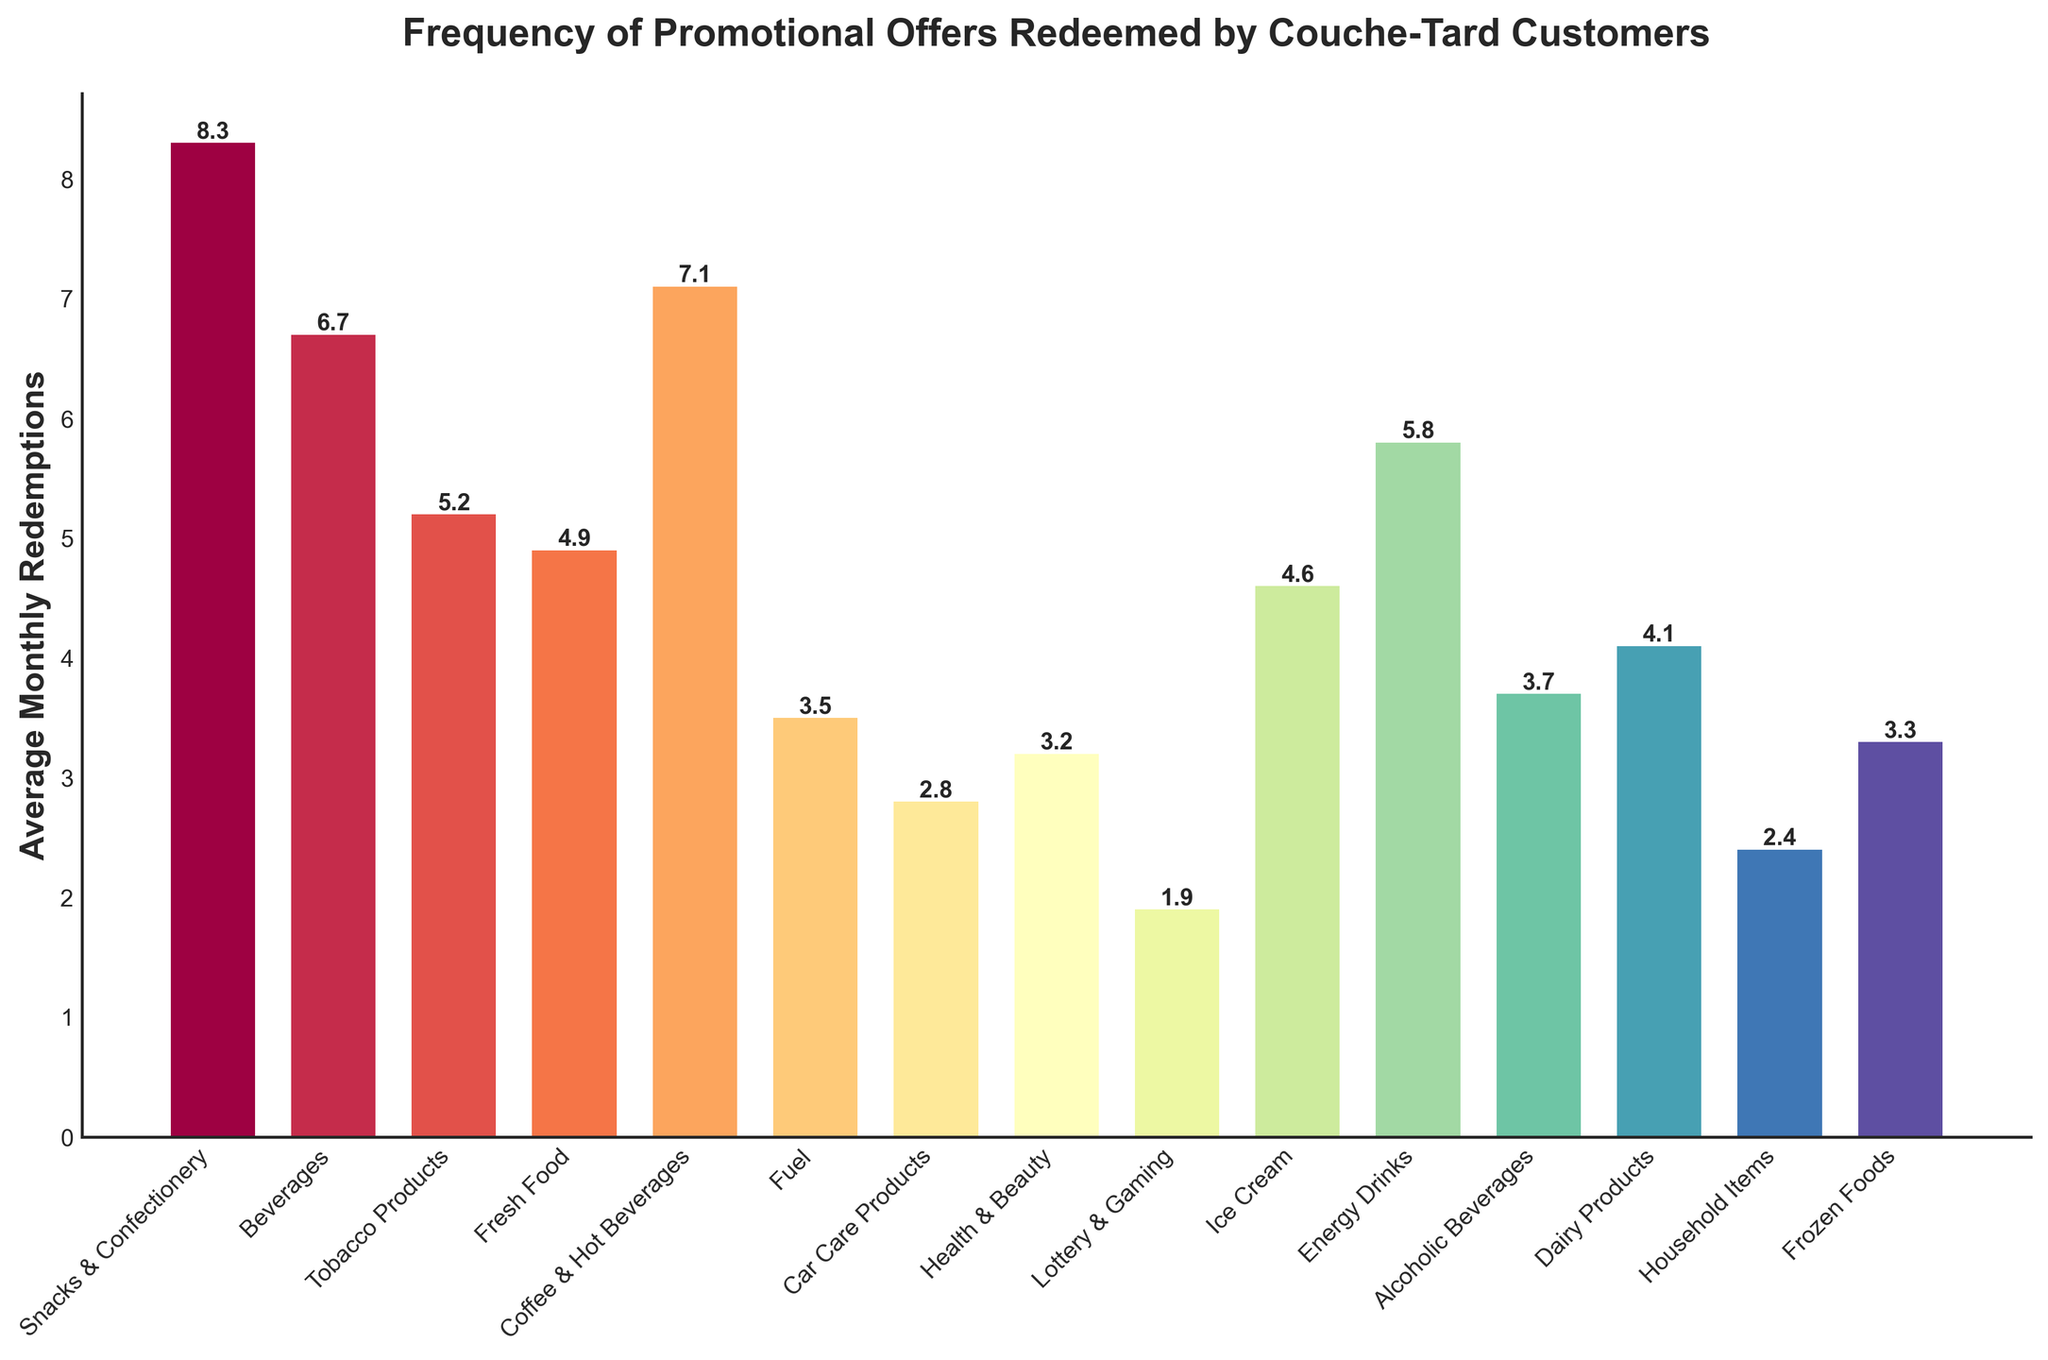Which product category has the highest average monthly redemptions? The tallest bar in the bar chart represents the category with the highest average monthly redemptions. The bar for "Snacks & Confectionery" is the tallest.
Answer: Snacks & Confectionery What is the difference in average monthly redemptions between the highest and lowest categories? The highest category is "Snacks & Confectionery" with 8.3 redemptions, and the lowest is "Lottery & Gaming" with 1.9 redemptions. The difference is 8.3 - 1.9 = 6.4.
Answer: 6.4 Which categories have average monthly redemptions higher than 6? By visually identifying the bars taller than the line representing 6, the categories that have higher values are "Snacks & Confectionery", "Beverages", and "Coffee & Hot Beverages".
Answer: Snacks & Confectionery, Beverages, Coffee & Hot Beverages How many categories have an average monthly redemption of less than 4? Count the number of bars that have heights less than the line representing 4 on the y-axis. These categories are "Fuel", "Car Care Products", "Health & Beauty", "Lottery & Gaming", "Household Items", and "Frozen Foods", making a total of 6 categories.
Answer: 6 What is the combined average monthly redemptions for "Fuel" and "Car Care Products"? Look at the values for both categories, which are 3.5 and 2.8 respectively. Adding them: 3.5 + 2.8 = 6.3.
Answer: 6.3 What is the average monthly redemptions for the "Ice Cream" and "Energy Drinks" categories? From the chart, the average for "Ice Cream" is 4.6 and for "Energy Drinks" is 5.8. The combined value is 4.6 + 5.8 = 10.4.
Answer: 10.4 Which category has lower average monthly redemptions: "Dairy Products" or "Frozen Foods"? Compare the heights of the bar for "Dairy Products" (4.1) and "Frozen Foods" (3.3). "Frozen Foods" has the lower value.
Answer: Frozen Foods What is the average monthly redemption value for the "Health & Beauty" category? The height of the bar representing "Health & Beauty" shows an average monthly redemption of 3.2.
Answer: 3.2 Are there any categories with average monthly redemptions exactly at 5? By examining the heights of the bars, only "Tobacco Products" has an average monthly redemption value close to 5, but it's actually 5.2. So, no categories match exactly 5.
Answer: No Which categories have average monthly redemptions between 4 and 5? Visually identify the bars that fall within the range between 4 and 5 on the y-axis. These are "Fresh Food" (4.9), "Dairy Products" (4.1), and "Ice Cream" (4.6).
Answer: Fresh Food, Dairy Products, Ice Cream 